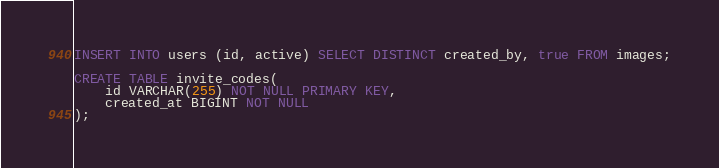Convert code to text. <code><loc_0><loc_0><loc_500><loc_500><_SQL_>INSERT INTO users (id, active) SELECT DISTINCT created_by, true FROM images;

CREATE TABLE invite_codes(
    id VARCHAR(255) NOT NULL PRIMARY KEY,
    created_at BIGINT NOT NULL
);
</code> 